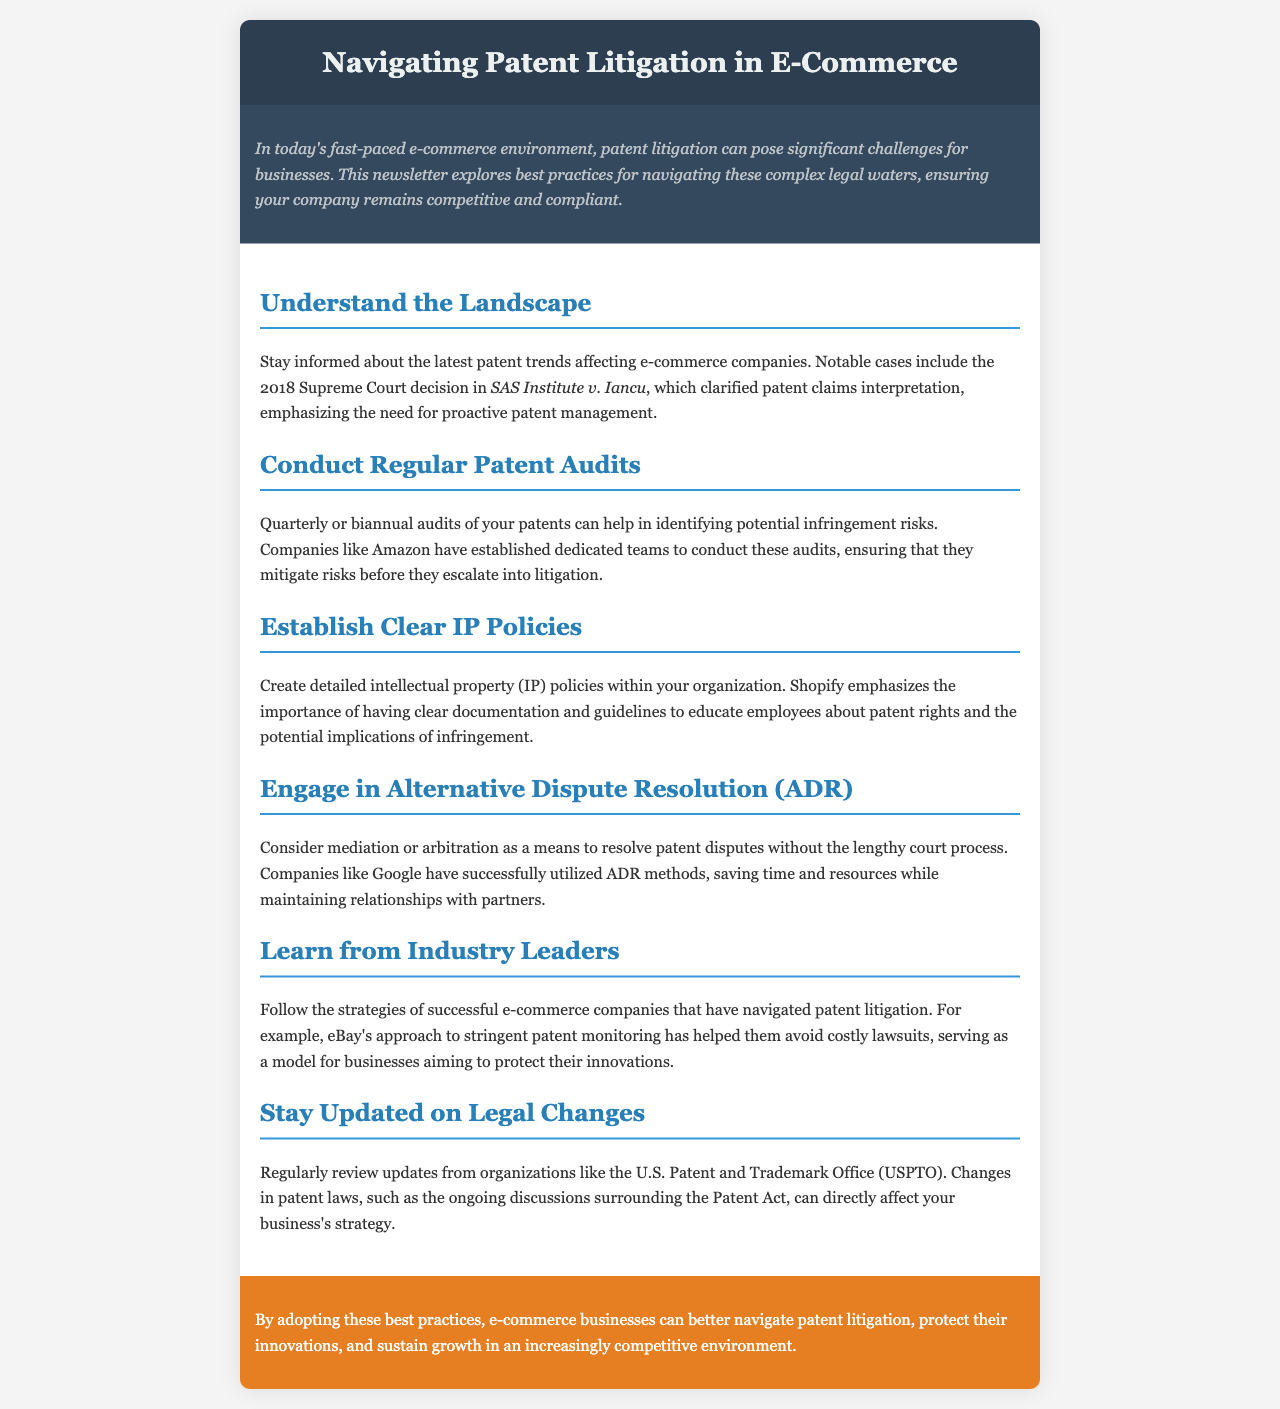What is the main theme of the newsletter? The main theme of the newsletter is about navigating patent litigation issues specific to e-commerce businesses.
Answer: Navigating patent litigation in e-commerce Which notable case is mentioned? The newsletter references a significant Supreme Court decision that impacts patent interpretation in relation to e-commerce.
Answer: SAS Institute v. Iancu How often should companies conduct patent audits? The document suggests a frequency for conducting audits to manage patent-related risks effectively.
Answer: Quarterly or biannual Which company is noted for establishing dedicated patent audit teams? The newsletter highlights a specific e-commerce company recognized for its proactive patent management approach.
Answer: Amazon What alternative dispute resolution method is suggested? The newsletter discusses methods for resolving disputes without court litigation.
Answer: Mediation or arbitration What is emphasized as important for developing internal practices? The content points out the necessity of having structured internal guidelines regarding intellectual property.
Answer: Clear IP policies Which organization should businesses regularly review for legal updates? The document identifies an organization that provides crucial updates on patent law and related changes.
Answer: U.S. Patent and Trademark Office (USPTO) Which e-commerce company’s patent monitoring strategy is highlighted? A specific e-commerce firm's approach to avoid litigation through effective patent oversight is mentioned.
Answer: eBay 